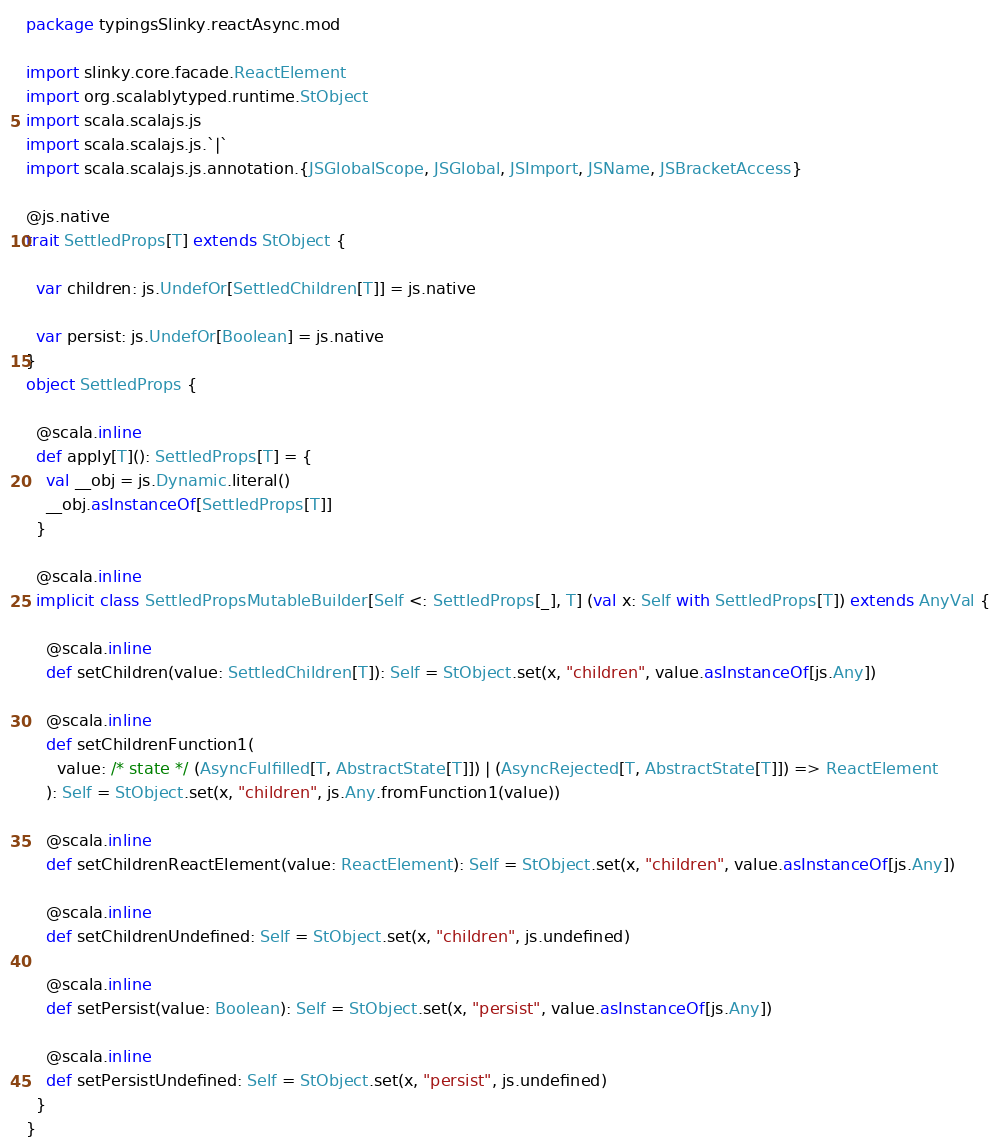Convert code to text. <code><loc_0><loc_0><loc_500><loc_500><_Scala_>package typingsSlinky.reactAsync.mod

import slinky.core.facade.ReactElement
import org.scalablytyped.runtime.StObject
import scala.scalajs.js
import scala.scalajs.js.`|`
import scala.scalajs.js.annotation.{JSGlobalScope, JSGlobal, JSImport, JSName, JSBracketAccess}

@js.native
trait SettledProps[T] extends StObject {
  
  var children: js.UndefOr[SettledChildren[T]] = js.native
  
  var persist: js.UndefOr[Boolean] = js.native
}
object SettledProps {
  
  @scala.inline
  def apply[T](): SettledProps[T] = {
    val __obj = js.Dynamic.literal()
    __obj.asInstanceOf[SettledProps[T]]
  }
  
  @scala.inline
  implicit class SettledPropsMutableBuilder[Self <: SettledProps[_], T] (val x: Self with SettledProps[T]) extends AnyVal {
    
    @scala.inline
    def setChildren(value: SettledChildren[T]): Self = StObject.set(x, "children", value.asInstanceOf[js.Any])
    
    @scala.inline
    def setChildrenFunction1(
      value: /* state */ (AsyncFulfilled[T, AbstractState[T]]) | (AsyncRejected[T, AbstractState[T]]) => ReactElement
    ): Self = StObject.set(x, "children", js.Any.fromFunction1(value))
    
    @scala.inline
    def setChildrenReactElement(value: ReactElement): Self = StObject.set(x, "children", value.asInstanceOf[js.Any])
    
    @scala.inline
    def setChildrenUndefined: Self = StObject.set(x, "children", js.undefined)
    
    @scala.inline
    def setPersist(value: Boolean): Self = StObject.set(x, "persist", value.asInstanceOf[js.Any])
    
    @scala.inline
    def setPersistUndefined: Self = StObject.set(x, "persist", js.undefined)
  }
}
</code> 